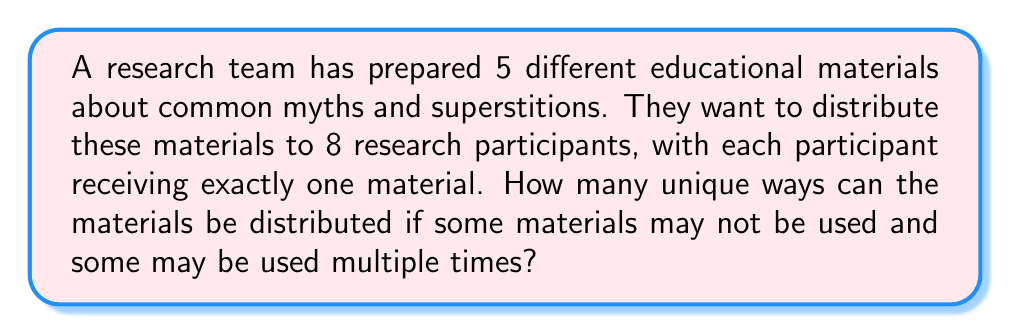Solve this math problem. Let's approach this step-by-step:

1) This is a problem of distributing distinct objects (the 5 educational materials) into distinct boxes (the 8 participants), where repetition is allowed.

2) For each participant, we have 5 choices of materials to give them.

3) Since the choices for each participant are independent, and we need to make a choice for all 8 participants, we can use the multiplication principle.

4) The total number of ways to distribute the materials is:

   $$5 \times 5 \times 5 \times 5 \times 5 \times 5 \times 5 \times 5 = 5^8$$

5) We can also write this as:

   $$\underbrace{5 \times 5 \times ... \times 5}_{8\text{ times}} = 5^8$$

6) To calculate $5^8$:
   
   $$5^8 = 390,625$$

Therefore, there are 390,625 unique ways to distribute the materials.
Answer: $390,625$ 